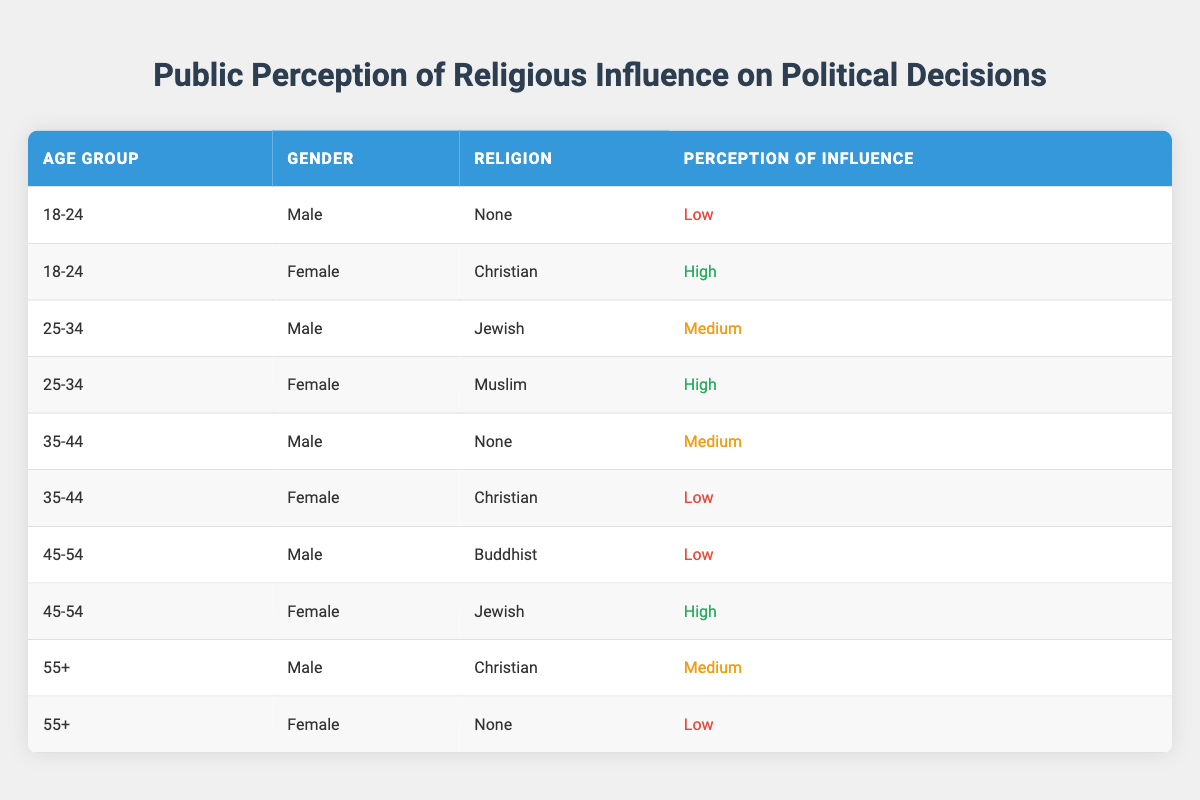What is the perception of influence for female respondents aged 18-24? Looking at the table, the female respondent in the 18-24 age group identifies as Christian with a perception of influence categorized as High.
Answer: High How many respondents perceive a High influence of religion on political decisions? There are two respondents with a High perception of influence: one female in the 18-24 age group (Christian) and one female in the 45-54 age group (Jewish), totaling two.
Answer: 2 Is it true that all respondents aged 55 and older have a Low perception of influence? In the table, one male in the 55+ age group (Christian) has a Medium perception of influence, contradicting the statement. Therefore, it is false that all have a Low perception.
Answer: No What is the average perception of influence for male respondents across all age groups? The perceptions for male respondents are: Low, Medium, Medium, Low, and Medium (from age groups 18-24, 35-44, 25-34, 45-54, and 55+ respectively). Assigning numerical values (Low=1, Medium=2, High=3), we have (1 + 2 + 2 + 1 + 2) / 5 = 1.6, resulting in an average perception of influence of 1.6.
Answer: 1.6 Which demographic group has the highest perception of influence? Analyzing the data, the female respondents aged 25-34 (Muslim) and 45-54 (Jewish) both have a High perception of influence, making these two groups the highest in the dataset.
Answer: Female respondents aged 25-34 and 45-54 How many respondents perceive a Medium influence of religion on political decisions? The respondents with a Medium perception are one male aged 25-34 (Jewish), one male aged 35-44 (None), and one male aged 55+ (Christian), amounting to three total.
Answer: 3 Do any male respondents perceive a High influence of religion on political decisions? Only one male respondent aged 25-34 identifies as Jewish and has a Medium perception of influence, so there are no males in the dataset with a High perception.
Answer: No What is the perception of influence for female Muslim respondents in the 25-34 age group? In the table, the female respondent in this category perceives influence as High.
Answer: High 